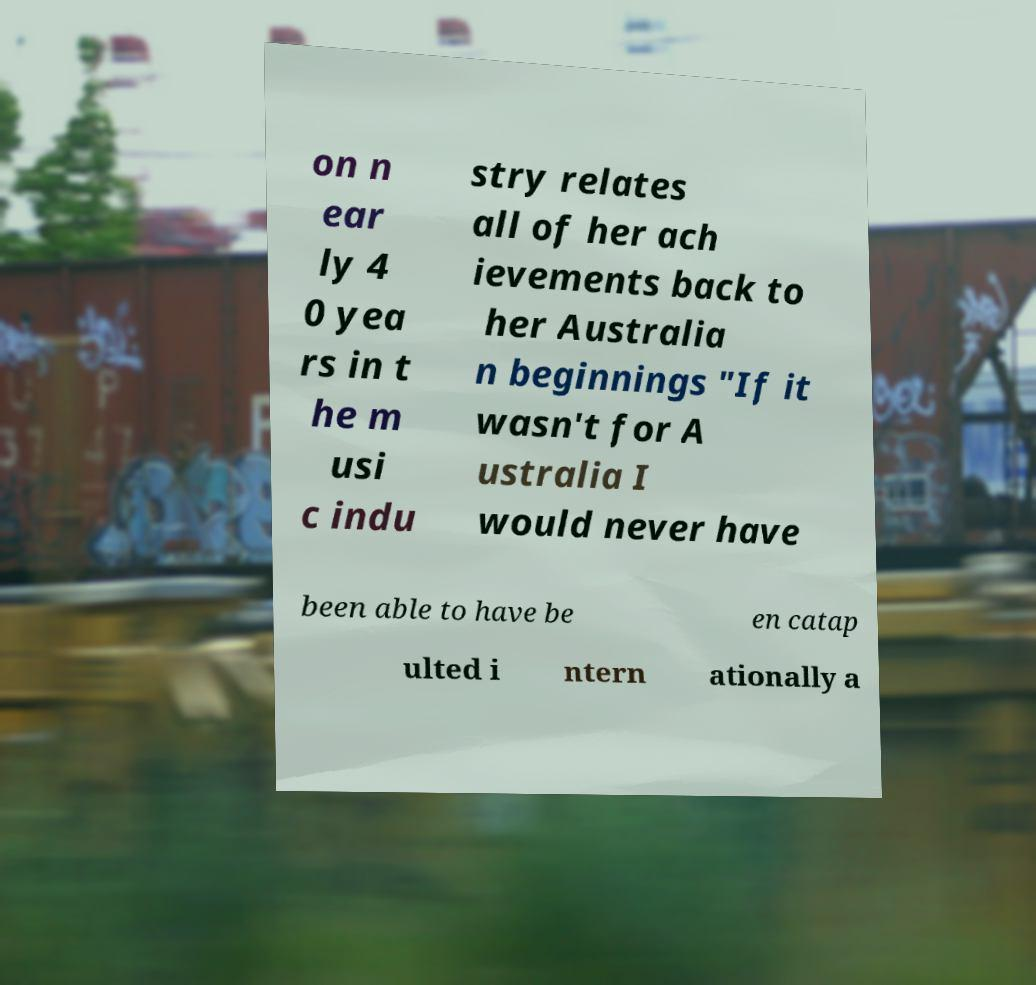Please identify and transcribe the text found in this image. on n ear ly 4 0 yea rs in t he m usi c indu stry relates all of her ach ievements back to her Australia n beginnings "If it wasn't for A ustralia I would never have been able to have be en catap ulted i ntern ationally a 